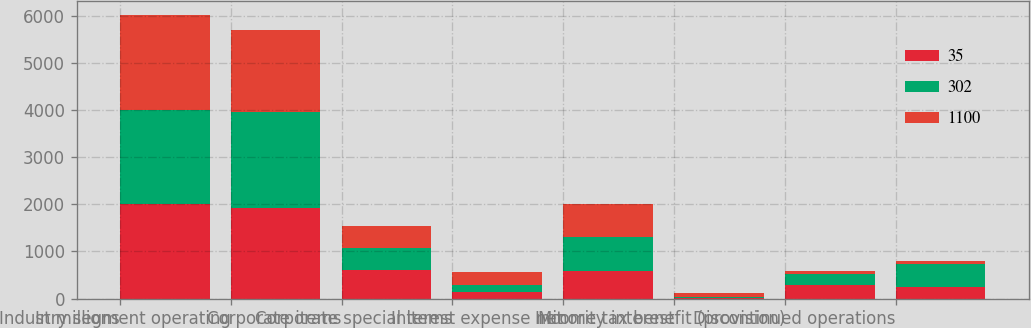<chart> <loc_0><loc_0><loc_500><loc_500><stacked_bar_chart><ecel><fcel>In millions<fcel>Industry segment operating<fcel>Corporate items<fcel>Corporate special items<fcel>Interest expense net<fcel>Minority interest<fcel>Income tax benefit (provision)<fcel>Discontinued operations<nl><fcel>35<fcel>2005<fcel>1923<fcel>597<fcel>147<fcel>593<fcel>12<fcel>285<fcel>241<nl><fcel>302<fcel>2004<fcel>2040<fcel>469<fcel>142<fcel>710<fcel>21<fcel>242<fcel>491<nl><fcel>1100<fcel>2003<fcel>1734<fcel>466<fcel>281<fcel>705<fcel>80<fcel>56<fcel>57<nl></chart> 